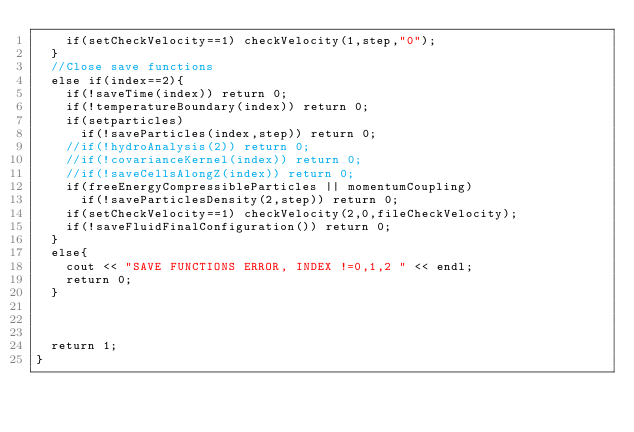Convert code to text. <code><loc_0><loc_0><loc_500><loc_500><_Cuda_>    if(setCheckVelocity==1) checkVelocity(1,step,"0");
  }
  //Close save functions
  else if(index==2){
    if(!saveTime(index)) return 0;
    if(!temperatureBoundary(index)) return 0;
    if(setparticles)
      if(!saveParticles(index,step)) return 0;
    //if(!hydroAnalysis(2)) return 0;
    //if(!covarianceKernel(index)) return 0;
    //if(!saveCellsAlongZ(index)) return 0;
    if(freeEnergyCompressibleParticles || momentumCoupling)
      if(!saveParticlesDensity(2,step)) return 0;
    if(setCheckVelocity==1) checkVelocity(2,0,fileCheckVelocity);
    if(!saveFluidFinalConfiguration()) return 0;
  }
  else{
    cout << "SAVE FUNCTIONS ERROR, INDEX !=0,1,2 " << endl;
    return 0;
  }
  


  return 1;
}
</code> 